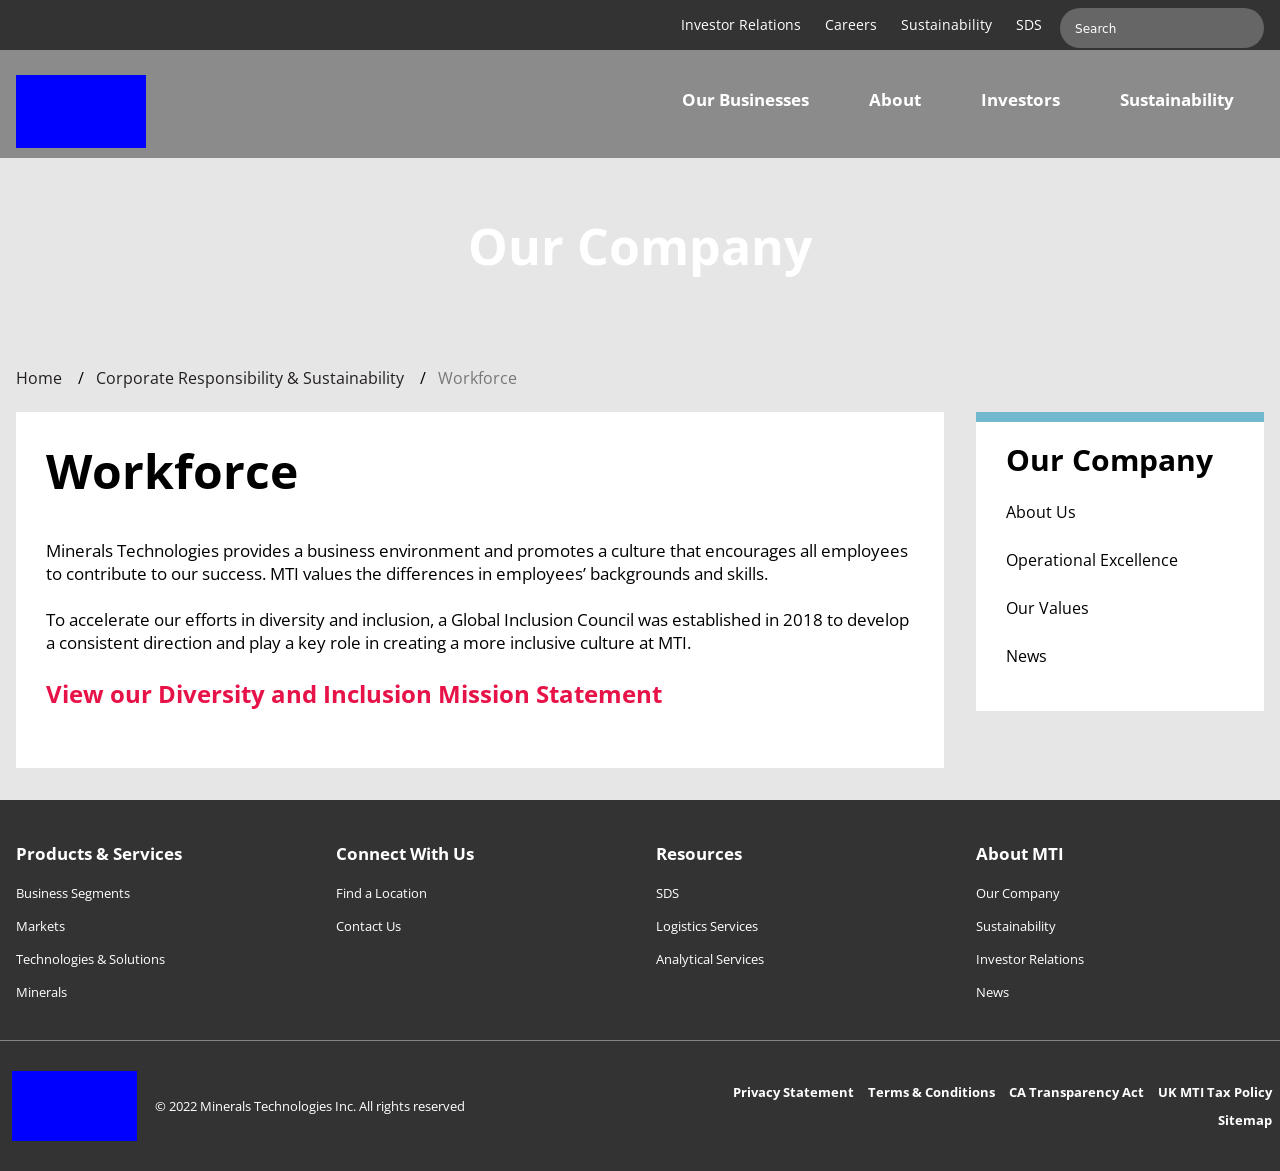What's the procedure for constructing this website from scratch with HTML? To build a website similar to the one shown in the image from scratch using HTML, you'd begin by structuring your HTML to include elements such as headers, main content areas, and footers. Use <header>, <main>, and <footer> tags to define these sections. Within the <header>, include navigation links with <nav> and <ul>/<li> tags. For the main content that appears to focus on company operations like 'Our Company', 'Products & Services', use <div> or <section> tags for each content area. End with a footer section using the <footer> tag, describing terms, privacy policies, and copyright information. 